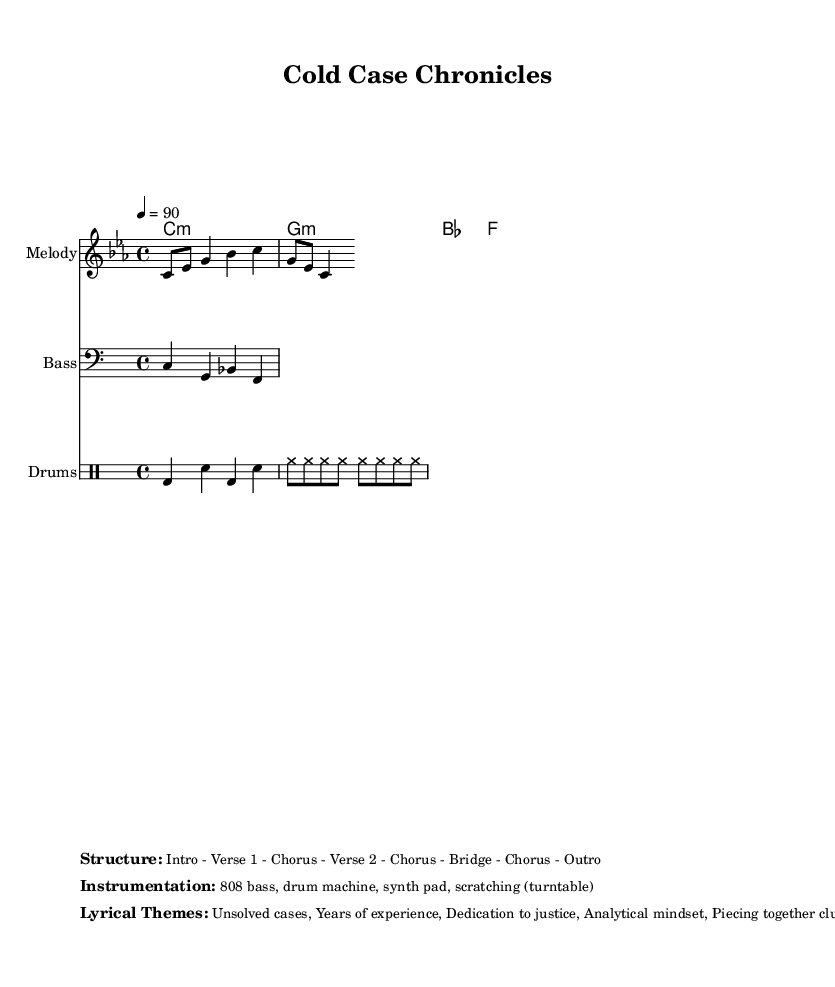What is the key signature of this music? The key signature indicates C minor, identifiable by three flats. The absence of sharps and the presence of three flats in the signature clearly tell us the piece is in C minor.
Answer: C minor What is the time signature of this music? The time signature shows 4/4, which means four beats per measure. This can be seen at the beginning of the score where the time signature is notated.
Answer: 4/4 What is the tempo of this music? The tempo marked is 90 beats per minute, indicated by the notation at the start of the score. This defines the speed at which the piece should be played.
Answer: 90 How many verses are in the structure? The structure outlines two verses, as indicated by the terms "Verse 1" and "Verse 2." This shows that the composition has separate sections dedicated to lyrical themes.
Answer: 2 What is the primary lyrical theme of this piece? The main lyrical theme indicated in the sheet music is dedication to justice. This is emphasized as a key point in the thematic summary provided in the markup section.
Answer: Dedication to justice Identify the type of drum used in this music. The score specifies a drum machine is utilized, which is a common element in Hip Hop music. This is mentioned in the instrumentation section indicating the type of sounds produced.
Answer: Drum machine What is the total number of measures shown in the score? The score does not have bar numbers; however, by analyzing the number of chords and other components in the sections, one can logically deduce there are several measures throughout typical segments in the hip hop structure.
Answer: 8 